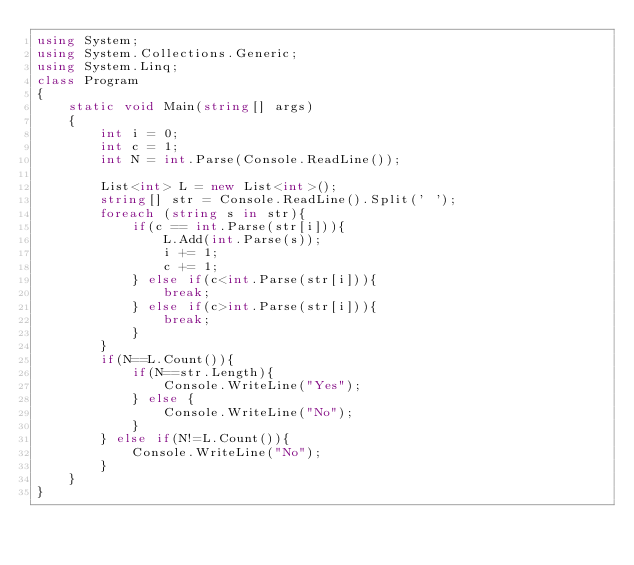Convert code to text. <code><loc_0><loc_0><loc_500><loc_500><_C#_>using System;
using System.Collections.Generic;
using System.Linq;
class Program
{
    static void Main(string[] args)
    {
        int i = 0;
        int c = 1;
        int N = int.Parse(Console.ReadLine());

        List<int> L = new List<int>();
        string[] str = Console.ReadLine().Split(' ');
        foreach (string s in str){
            if(c == int.Parse(str[i])){
                L.Add(int.Parse(s));
                i += 1;
                c += 1;
            } else if(c<int.Parse(str[i])){
                break;
            } else if(c>int.Parse(str[i])){
                break;
            }
        }  
        if(N==L.Count()){
            if(N==str.Length){
                Console.WriteLine("Yes");
            } else {
                Console.WriteLine("No");
            }
        } else if(N!=L.Count()){
            Console.WriteLine("No");
        } 
    }
}</code> 